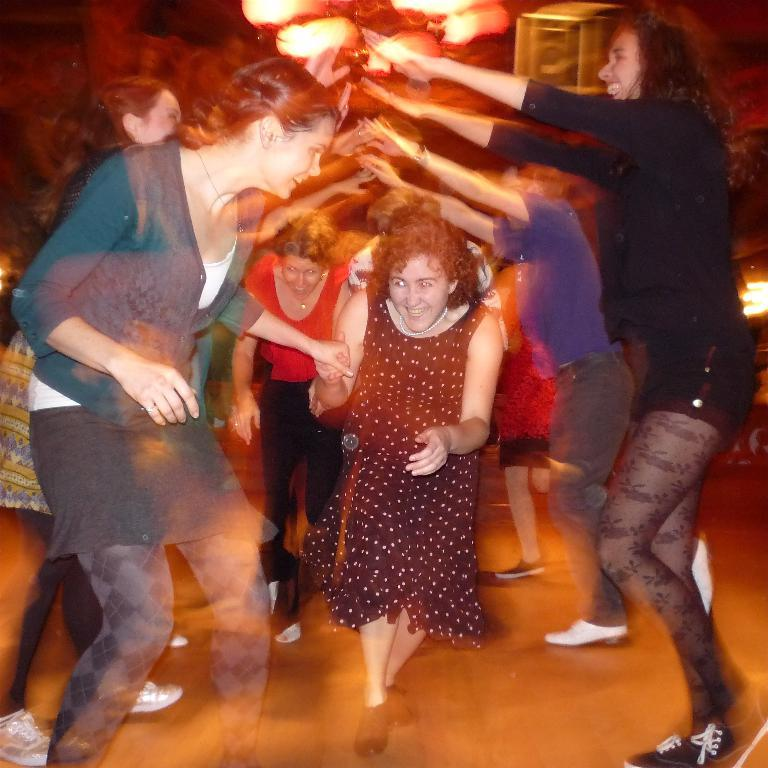How many people are in the image? There is a group of people in the image. What are the people doing in the image? The people are standing and smiling. What can be seen in the background of the image? There are lights visible in the background of the image. What type of feather is present in the image? There is no feather present in the image. 